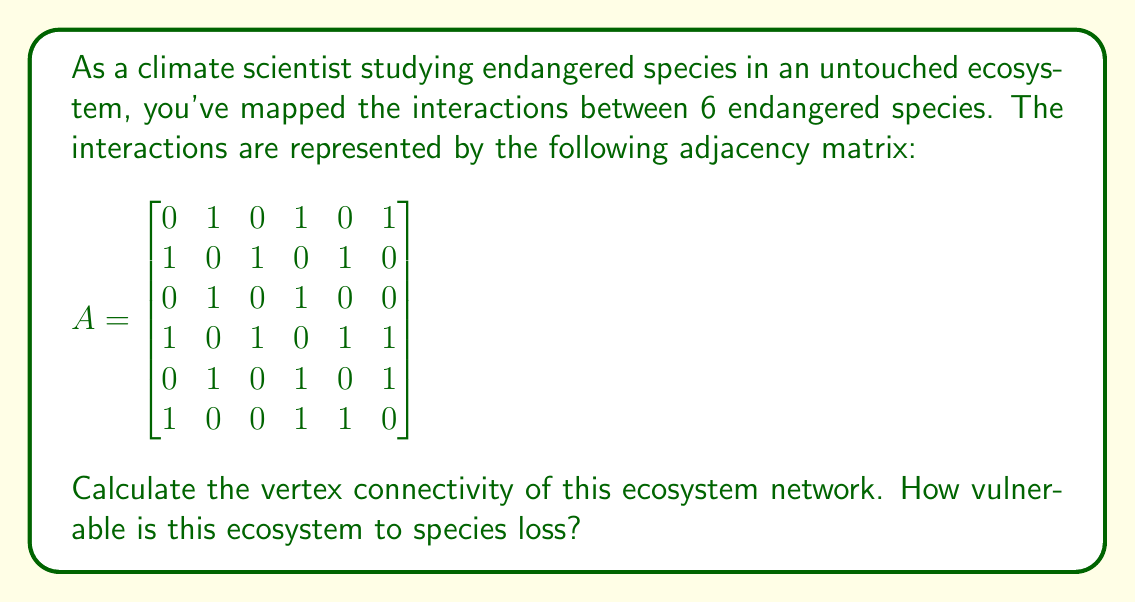Give your solution to this math problem. To solve this problem, we need to understand and calculate the vertex connectivity of the given graph. The vertex connectivity, denoted as $\kappa(G)$, is the minimum number of vertices that need to be removed to disconnect the graph.

Step 1: Analyze the graph structure
From the adjacency matrix, we can see that the graph is connected (there's a path between any two vertices) and undirected (the matrix is symmetric).

Step 2: Calculate the minimum degree
The minimum degree of a vertex in the graph is a quick upper bound for vertex connectivity. From the adjacency matrix:
- Vertex 1, 2, 5, 6 have degree 3
- Vertex 3 has degree 2
- Vertex 4 has degree 4

The minimum degree is 2.

Step 3: Check for cut vertices
A cut vertex is a vertex whose removal disconnects the graph. We need to check if there are any cut vertices:
- Removing vertex 3 doesn't disconnect the graph
- Removing vertex 1, 2, 4, 5, or 6 also doesn't disconnect the graph

There are no cut vertices in this graph.

Step 4: Check for vertex cuts of size 2
Since there are no cut vertices, we need to check if there's a pair of vertices whose removal disconnects the graph. After checking all possible pairs, we find that removing vertices 2 and 4 disconnects the graph into three components: {1}, {3}, and {5,6}.

Step 5: Conclude the vertex connectivity
Since we found a vertex cut of size 2, and there are no cut vertices (vertex cuts of size 1), the vertex connectivity of this graph is 2.

Interpretation: The vertex connectivity of 2 means that this ecosystem is moderately vulnerable to species loss. It would take the removal of at least two species to completely disrupt the interaction network. While not extremely fragile, it's not highly resilient either, emphasizing the importance of conservation efforts.
Answer: The vertex connectivity of the ecosystem network is 2. 